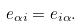Convert formula to latex. <formula><loc_0><loc_0><loc_500><loc_500>e _ { \alpha i } = e _ { i \alpha } .</formula> 